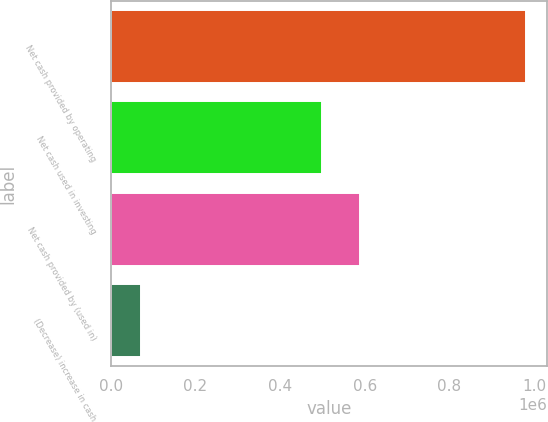Convert chart to OTSL. <chart><loc_0><loc_0><loc_500><loc_500><bar_chart><fcel>Net cash provided by operating<fcel>Net cash used in investing<fcel>Net cash provided by (used in)<fcel>(Decrease) increase in cash<nl><fcel>982310<fcel>498324<fcel>589552<fcel>70030<nl></chart> 